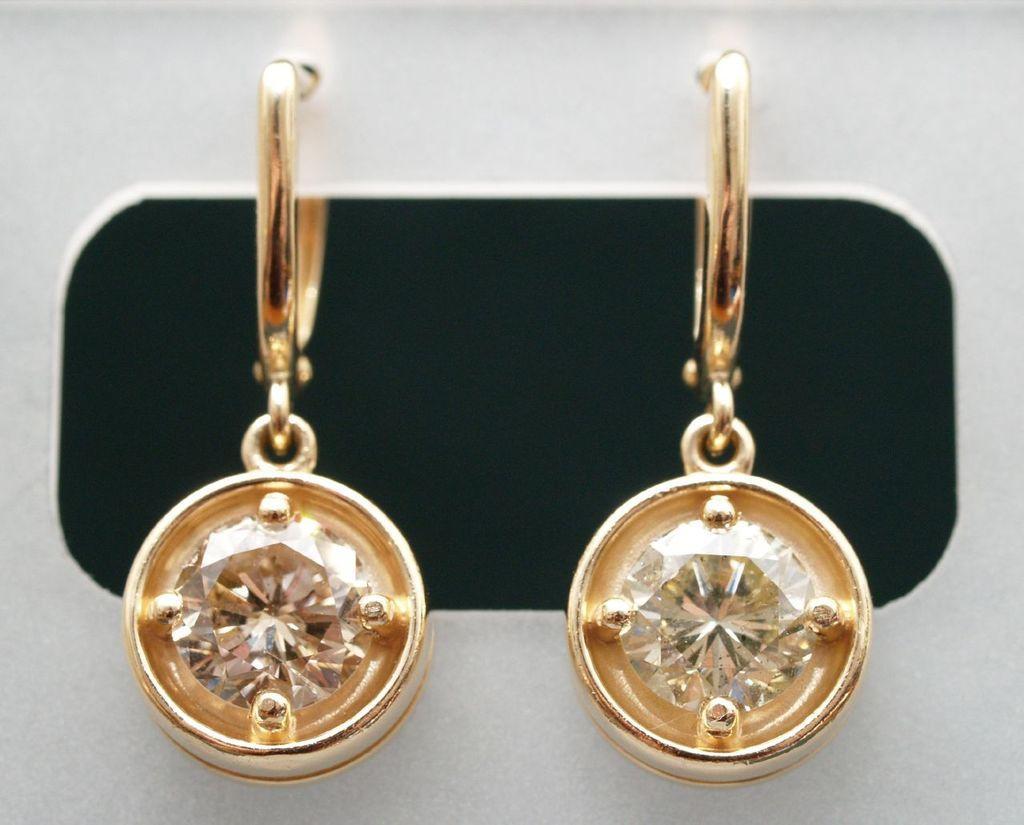Could you give a brief overview of what you see in this image? In this image there is a pair of earrings. 